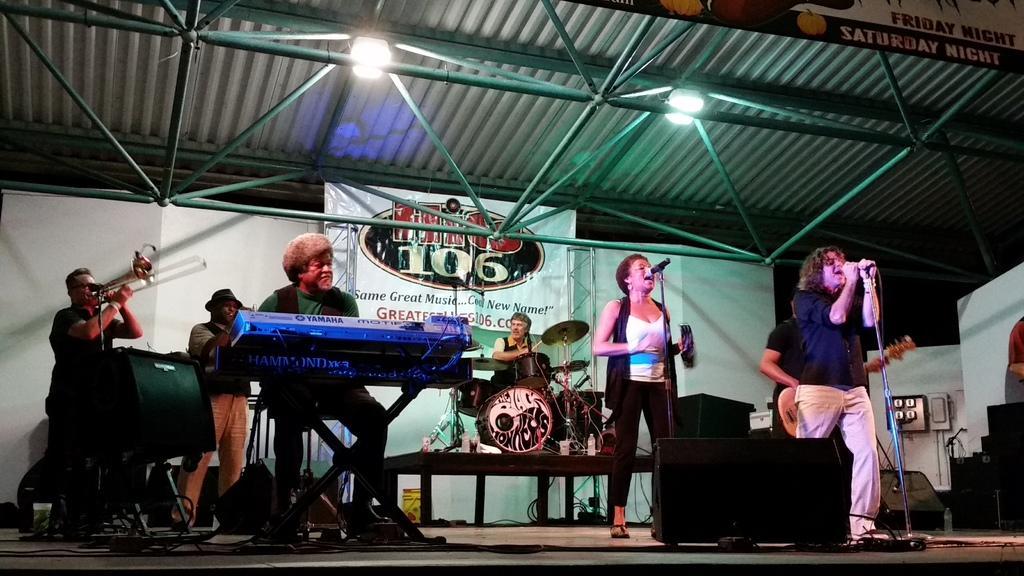How would you summarize this image in a sentence or two? In this picture there is a woman who is wearing white t-shirt, trouser and sandal. She is singing in front of the mic. In front of her there is a man who is wearing blue t-shirt and shoes. And he is holding a mic, besides him there is a man who is playing a guitar. In the center there is a man who is sitting on the chair and playing a drum. On the left there is a man who is playing a flute. Beside them there is another man who is also playing a flute. In front of them there is a man who is playing a piano. Besides him I can see the speaker. At the top I can see some lights which are placed on the shed. In the top right corner there is a banner. 